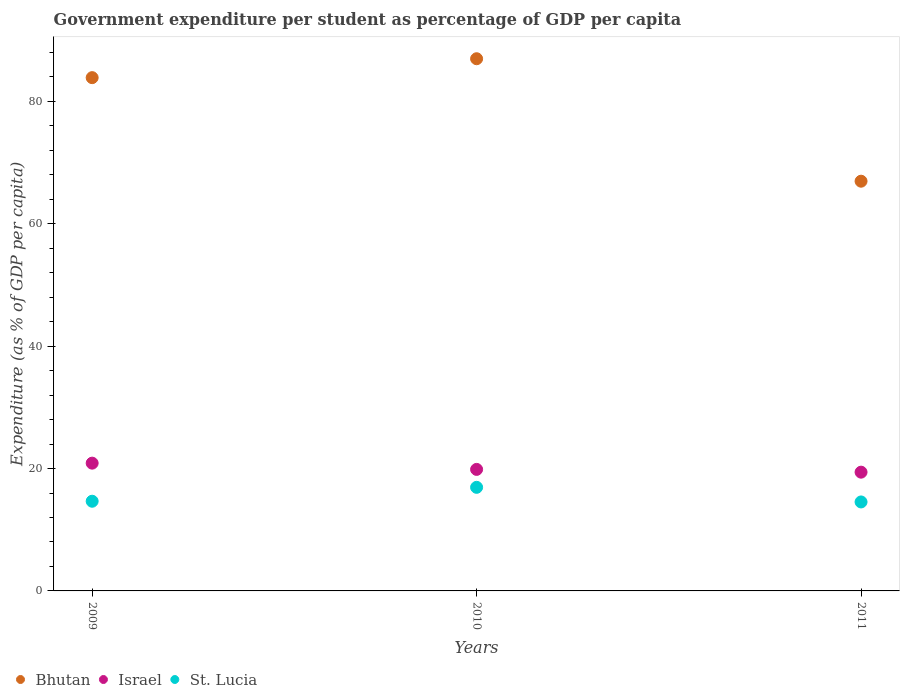How many different coloured dotlines are there?
Your answer should be compact. 3. Is the number of dotlines equal to the number of legend labels?
Your answer should be compact. Yes. What is the percentage of expenditure per student in Bhutan in 2010?
Make the answer very short. 86.98. Across all years, what is the maximum percentage of expenditure per student in St. Lucia?
Your answer should be very brief. 16.93. Across all years, what is the minimum percentage of expenditure per student in St. Lucia?
Your response must be concise. 14.54. In which year was the percentage of expenditure per student in St. Lucia maximum?
Provide a short and direct response. 2010. In which year was the percentage of expenditure per student in Bhutan minimum?
Provide a short and direct response. 2011. What is the total percentage of expenditure per student in Bhutan in the graph?
Make the answer very short. 237.83. What is the difference between the percentage of expenditure per student in Bhutan in 2010 and that in 2011?
Your answer should be compact. 20.01. What is the difference between the percentage of expenditure per student in St. Lucia in 2011 and the percentage of expenditure per student in Israel in 2009?
Your answer should be very brief. -6.34. What is the average percentage of expenditure per student in St. Lucia per year?
Your answer should be compact. 15.38. In the year 2011, what is the difference between the percentage of expenditure per student in St. Lucia and percentage of expenditure per student in Israel?
Make the answer very short. -4.87. What is the ratio of the percentage of expenditure per student in Israel in 2010 to that in 2011?
Ensure brevity in your answer.  1.02. What is the difference between the highest and the second highest percentage of expenditure per student in Bhutan?
Your answer should be compact. 3.09. What is the difference between the highest and the lowest percentage of expenditure per student in Israel?
Provide a short and direct response. 1.47. Is the percentage of expenditure per student in St. Lucia strictly greater than the percentage of expenditure per student in Bhutan over the years?
Offer a very short reply. No. How many years are there in the graph?
Offer a very short reply. 3. Does the graph contain any zero values?
Offer a terse response. No. Does the graph contain grids?
Your response must be concise. No. How many legend labels are there?
Your answer should be very brief. 3. What is the title of the graph?
Make the answer very short. Government expenditure per student as percentage of GDP per capita. Does "Kyrgyz Republic" appear as one of the legend labels in the graph?
Offer a terse response. No. What is the label or title of the X-axis?
Your response must be concise. Years. What is the label or title of the Y-axis?
Offer a very short reply. Expenditure (as % of GDP per capita). What is the Expenditure (as % of GDP per capita) in Bhutan in 2009?
Your answer should be compact. 83.89. What is the Expenditure (as % of GDP per capita) of Israel in 2009?
Your response must be concise. 20.88. What is the Expenditure (as % of GDP per capita) in St. Lucia in 2009?
Make the answer very short. 14.66. What is the Expenditure (as % of GDP per capita) in Bhutan in 2010?
Give a very brief answer. 86.98. What is the Expenditure (as % of GDP per capita) in Israel in 2010?
Make the answer very short. 19.86. What is the Expenditure (as % of GDP per capita) of St. Lucia in 2010?
Make the answer very short. 16.93. What is the Expenditure (as % of GDP per capita) in Bhutan in 2011?
Provide a short and direct response. 66.96. What is the Expenditure (as % of GDP per capita) in Israel in 2011?
Offer a very short reply. 19.41. What is the Expenditure (as % of GDP per capita) in St. Lucia in 2011?
Your answer should be very brief. 14.54. Across all years, what is the maximum Expenditure (as % of GDP per capita) of Bhutan?
Offer a terse response. 86.98. Across all years, what is the maximum Expenditure (as % of GDP per capita) of Israel?
Your response must be concise. 20.88. Across all years, what is the maximum Expenditure (as % of GDP per capita) in St. Lucia?
Ensure brevity in your answer.  16.93. Across all years, what is the minimum Expenditure (as % of GDP per capita) of Bhutan?
Offer a terse response. 66.96. Across all years, what is the minimum Expenditure (as % of GDP per capita) in Israel?
Ensure brevity in your answer.  19.41. Across all years, what is the minimum Expenditure (as % of GDP per capita) of St. Lucia?
Make the answer very short. 14.54. What is the total Expenditure (as % of GDP per capita) in Bhutan in the graph?
Give a very brief answer. 237.83. What is the total Expenditure (as % of GDP per capita) in Israel in the graph?
Your answer should be very brief. 60.15. What is the total Expenditure (as % of GDP per capita) in St. Lucia in the graph?
Make the answer very short. 46.13. What is the difference between the Expenditure (as % of GDP per capita) of Bhutan in 2009 and that in 2010?
Keep it short and to the point. -3.09. What is the difference between the Expenditure (as % of GDP per capita) in Israel in 2009 and that in 2010?
Make the answer very short. 1.02. What is the difference between the Expenditure (as % of GDP per capita) of St. Lucia in 2009 and that in 2010?
Provide a succinct answer. -2.27. What is the difference between the Expenditure (as % of GDP per capita) of Bhutan in 2009 and that in 2011?
Give a very brief answer. 16.92. What is the difference between the Expenditure (as % of GDP per capita) in Israel in 2009 and that in 2011?
Your response must be concise. 1.47. What is the difference between the Expenditure (as % of GDP per capita) of St. Lucia in 2009 and that in 2011?
Your answer should be very brief. 0.12. What is the difference between the Expenditure (as % of GDP per capita) in Bhutan in 2010 and that in 2011?
Provide a short and direct response. 20.01. What is the difference between the Expenditure (as % of GDP per capita) in Israel in 2010 and that in 2011?
Provide a short and direct response. 0.45. What is the difference between the Expenditure (as % of GDP per capita) of St. Lucia in 2010 and that in 2011?
Keep it short and to the point. 2.39. What is the difference between the Expenditure (as % of GDP per capita) of Bhutan in 2009 and the Expenditure (as % of GDP per capita) of Israel in 2010?
Provide a short and direct response. 64.03. What is the difference between the Expenditure (as % of GDP per capita) in Bhutan in 2009 and the Expenditure (as % of GDP per capita) in St. Lucia in 2010?
Offer a terse response. 66.96. What is the difference between the Expenditure (as % of GDP per capita) in Israel in 2009 and the Expenditure (as % of GDP per capita) in St. Lucia in 2010?
Your answer should be very brief. 3.95. What is the difference between the Expenditure (as % of GDP per capita) in Bhutan in 2009 and the Expenditure (as % of GDP per capita) in Israel in 2011?
Give a very brief answer. 64.48. What is the difference between the Expenditure (as % of GDP per capita) in Bhutan in 2009 and the Expenditure (as % of GDP per capita) in St. Lucia in 2011?
Your answer should be compact. 69.34. What is the difference between the Expenditure (as % of GDP per capita) in Israel in 2009 and the Expenditure (as % of GDP per capita) in St. Lucia in 2011?
Offer a terse response. 6.34. What is the difference between the Expenditure (as % of GDP per capita) of Bhutan in 2010 and the Expenditure (as % of GDP per capita) of Israel in 2011?
Your answer should be compact. 67.57. What is the difference between the Expenditure (as % of GDP per capita) of Bhutan in 2010 and the Expenditure (as % of GDP per capita) of St. Lucia in 2011?
Your answer should be very brief. 72.44. What is the difference between the Expenditure (as % of GDP per capita) of Israel in 2010 and the Expenditure (as % of GDP per capita) of St. Lucia in 2011?
Make the answer very short. 5.32. What is the average Expenditure (as % of GDP per capita) in Bhutan per year?
Provide a short and direct response. 79.28. What is the average Expenditure (as % of GDP per capita) of Israel per year?
Your answer should be very brief. 20.05. What is the average Expenditure (as % of GDP per capita) in St. Lucia per year?
Your response must be concise. 15.38. In the year 2009, what is the difference between the Expenditure (as % of GDP per capita) in Bhutan and Expenditure (as % of GDP per capita) in Israel?
Give a very brief answer. 63.01. In the year 2009, what is the difference between the Expenditure (as % of GDP per capita) of Bhutan and Expenditure (as % of GDP per capita) of St. Lucia?
Your answer should be very brief. 69.23. In the year 2009, what is the difference between the Expenditure (as % of GDP per capita) in Israel and Expenditure (as % of GDP per capita) in St. Lucia?
Make the answer very short. 6.22. In the year 2010, what is the difference between the Expenditure (as % of GDP per capita) in Bhutan and Expenditure (as % of GDP per capita) in Israel?
Provide a succinct answer. 67.12. In the year 2010, what is the difference between the Expenditure (as % of GDP per capita) of Bhutan and Expenditure (as % of GDP per capita) of St. Lucia?
Ensure brevity in your answer.  70.05. In the year 2010, what is the difference between the Expenditure (as % of GDP per capita) of Israel and Expenditure (as % of GDP per capita) of St. Lucia?
Provide a short and direct response. 2.93. In the year 2011, what is the difference between the Expenditure (as % of GDP per capita) in Bhutan and Expenditure (as % of GDP per capita) in Israel?
Offer a very short reply. 47.55. In the year 2011, what is the difference between the Expenditure (as % of GDP per capita) in Bhutan and Expenditure (as % of GDP per capita) in St. Lucia?
Provide a short and direct response. 52.42. In the year 2011, what is the difference between the Expenditure (as % of GDP per capita) in Israel and Expenditure (as % of GDP per capita) in St. Lucia?
Provide a succinct answer. 4.87. What is the ratio of the Expenditure (as % of GDP per capita) of Bhutan in 2009 to that in 2010?
Offer a terse response. 0.96. What is the ratio of the Expenditure (as % of GDP per capita) of Israel in 2009 to that in 2010?
Your answer should be very brief. 1.05. What is the ratio of the Expenditure (as % of GDP per capita) in St. Lucia in 2009 to that in 2010?
Make the answer very short. 0.87. What is the ratio of the Expenditure (as % of GDP per capita) of Bhutan in 2009 to that in 2011?
Provide a succinct answer. 1.25. What is the ratio of the Expenditure (as % of GDP per capita) in Israel in 2009 to that in 2011?
Give a very brief answer. 1.08. What is the ratio of the Expenditure (as % of GDP per capita) in St. Lucia in 2009 to that in 2011?
Your answer should be very brief. 1.01. What is the ratio of the Expenditure (as % of GDP per capita) in Bhutan in 2010 to that in 2011?
Keep it short and to the point. 1.3. What is the ratio of the Expenditure (as % of GDP per capita) of Israel in 2010 to that in 2011?
Keep it short and to the point. 1.02. What is the ratio of the Expenditure (as % of GDP per capita) of St. Lucia in 2010 to that in 2011?
Make the answer very short. 1.16. What is the difference between the highest and the second highest Expenditure (as % of GDP per capita) of Bhutan?
Offer a terse response. 3.09. What is the difference between the highest and the second highest Expenditure (as % of GDP per capita) of Israel?
Your answer should be compact. 1.02. What is the difference between the highest and the second highest Expenditure (as % of GDP per capita) in St. Lucia?
Offer a terse response. 2.27. What is the difference between the highest and the lowest Expenditure (as % of GDP per capita) in Bhutan?
Your answer should be very brief. 20.01. What is the difference between the highest and the lowest Expenditure (as % of GDP per capita) in Israel?
Provide a short and direct response. 1.47. What is the difference between the highest and the lowest Expenditure (as % of GDP per capita) of St. Lucia?
Provide a short and direct response. 2.39. 